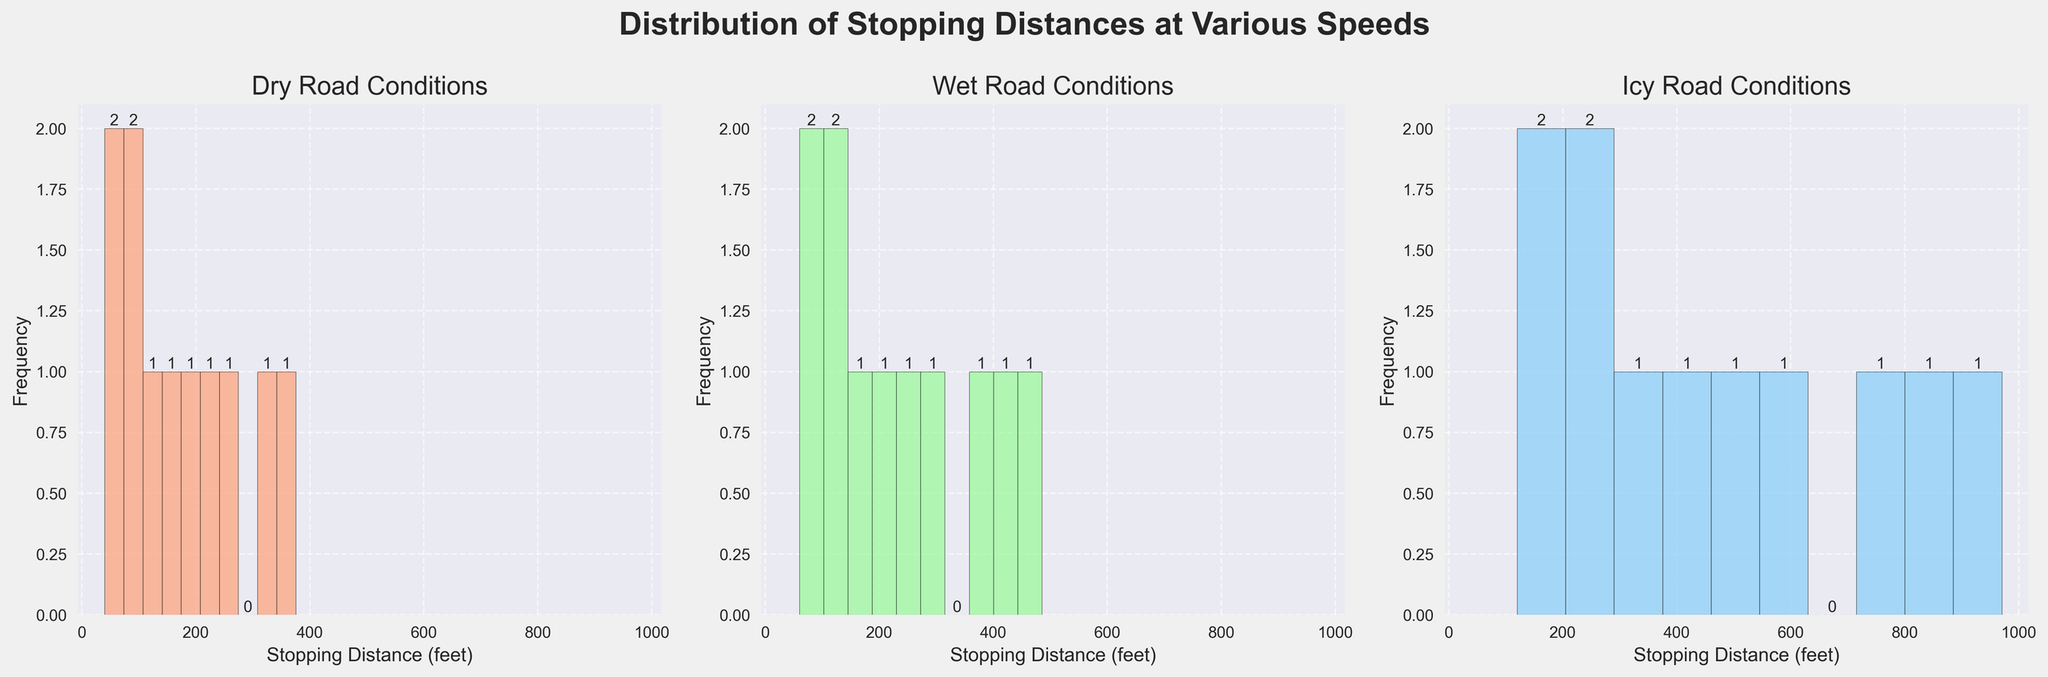what is the title of the figure? The title of the figure is prominently displayed at the top.
Answer: Distribution of Stopping Distances at Various Speeds Which road condition has the widest range of stopping distances? By observing the x-axis of each subplot, the range of stopping distances in the "Icy" road condition is the widest, extending up to 970 feet.
Answer: Icy How many bars are present in the histogram for dry road conditions? By counting the number of bars in the histogram for the dry conditions subplot, we find there are 10 bars.
Answer: 10 Compare the stopping distance frequency in dry and wet conditions: Which has more bars with a frequency above 1? By assessing and comparing the heights of the bars in the "Dry" and "Wet" conditions subplots, the "Wet" conditions histogram has more bars with a frequency above 1.
Answer: Wet If the total of stopping distances for dry conditions is 2,055 feet, what's the average stopping distance? To find the average stopping distance, divide the total stopping distance by the number of data points: 2,055 feet / 11 data points = 186.82 feet (rounding up).
Answer: 186.82 feet Which condition shows the highest stopping distance for a speed of 40 mph? Referring to the data and the histogram subplots, look for the stopping distance at 40 mph, "Icy" conditions have the highest stopping distance of 340 feet.
Answer: Icy Between dry and icy conditions, which has a more even distribution of stopping distances? Observing the histograms, the bars in the dry conditions subplot are more evenly spread out across the range, while the icy conditions show a sharp increase.
Answer: Dry At what speed do the wet and icy stopping distances both exceed 200 feet? By checking the data values and the subplots, we see that at 45 mph, both the wet (210 feet) and icy (420 feet) stopping distances exceed 200 feet.
Answer: 45 mph What's the highest frequency of any bar in the icy conditions histogram? By examining the tallest bar in the icy conditions subplot, the maximum frequency observed is 2.
Answer: 2 What’s the difference between the highest stopping distances on dry and wet conditions for the highest speed? The highest stopping distance on dry conditions at the highest speed (70 mph) is 375 feet, and for wet conditions, it is 485 feet. The difference is 485 - 375 = 110 feet.
Answer: 110 feet 